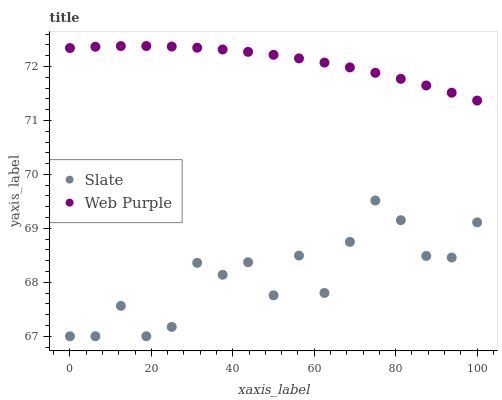Does Slate have the minimum area under the curve?
Answer yes or no. Yes. Does Web Purple have the maximum area under the curve?
Answer yes or no. Yes. Does Web Purple have the minimum area under the curve?
Answer yes or no. No. Is Web Purple the smoothest?
Answer yes or no. Yes. Is Slate the roughest?
Answer yes or no. Yes. Is Web Purple the roughest?
Answer yes or no. No. Does Slate have the lowest value?
Answer yes or no. Yes. Does Web Purple have the lowest value?
Answer yes or no. No. Does Web Purple have the highest value?
Answer yes or no. Yes. Is Slate less than Web Purple?
Answer yes or no. Yes. Is Web Purple greater than Slate?
Answer yes or no. Yes. Does Slate intersect Web Purple?
Answer yes or no. No. 